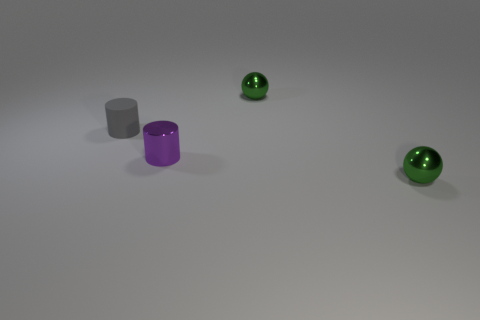Do the gray matte thing and the purple metallic object in front of the small gray rubber cylinder have the same shape? Yes, the gray matte object and the purple metallic object both appear to have cylindrical shapes, although their colors and textures differ. The gray object has a matte finish, giving it a non-reflective surface, whereas the purple object has a metallic sheen, reflecting light and giving it a shiny appearance. 